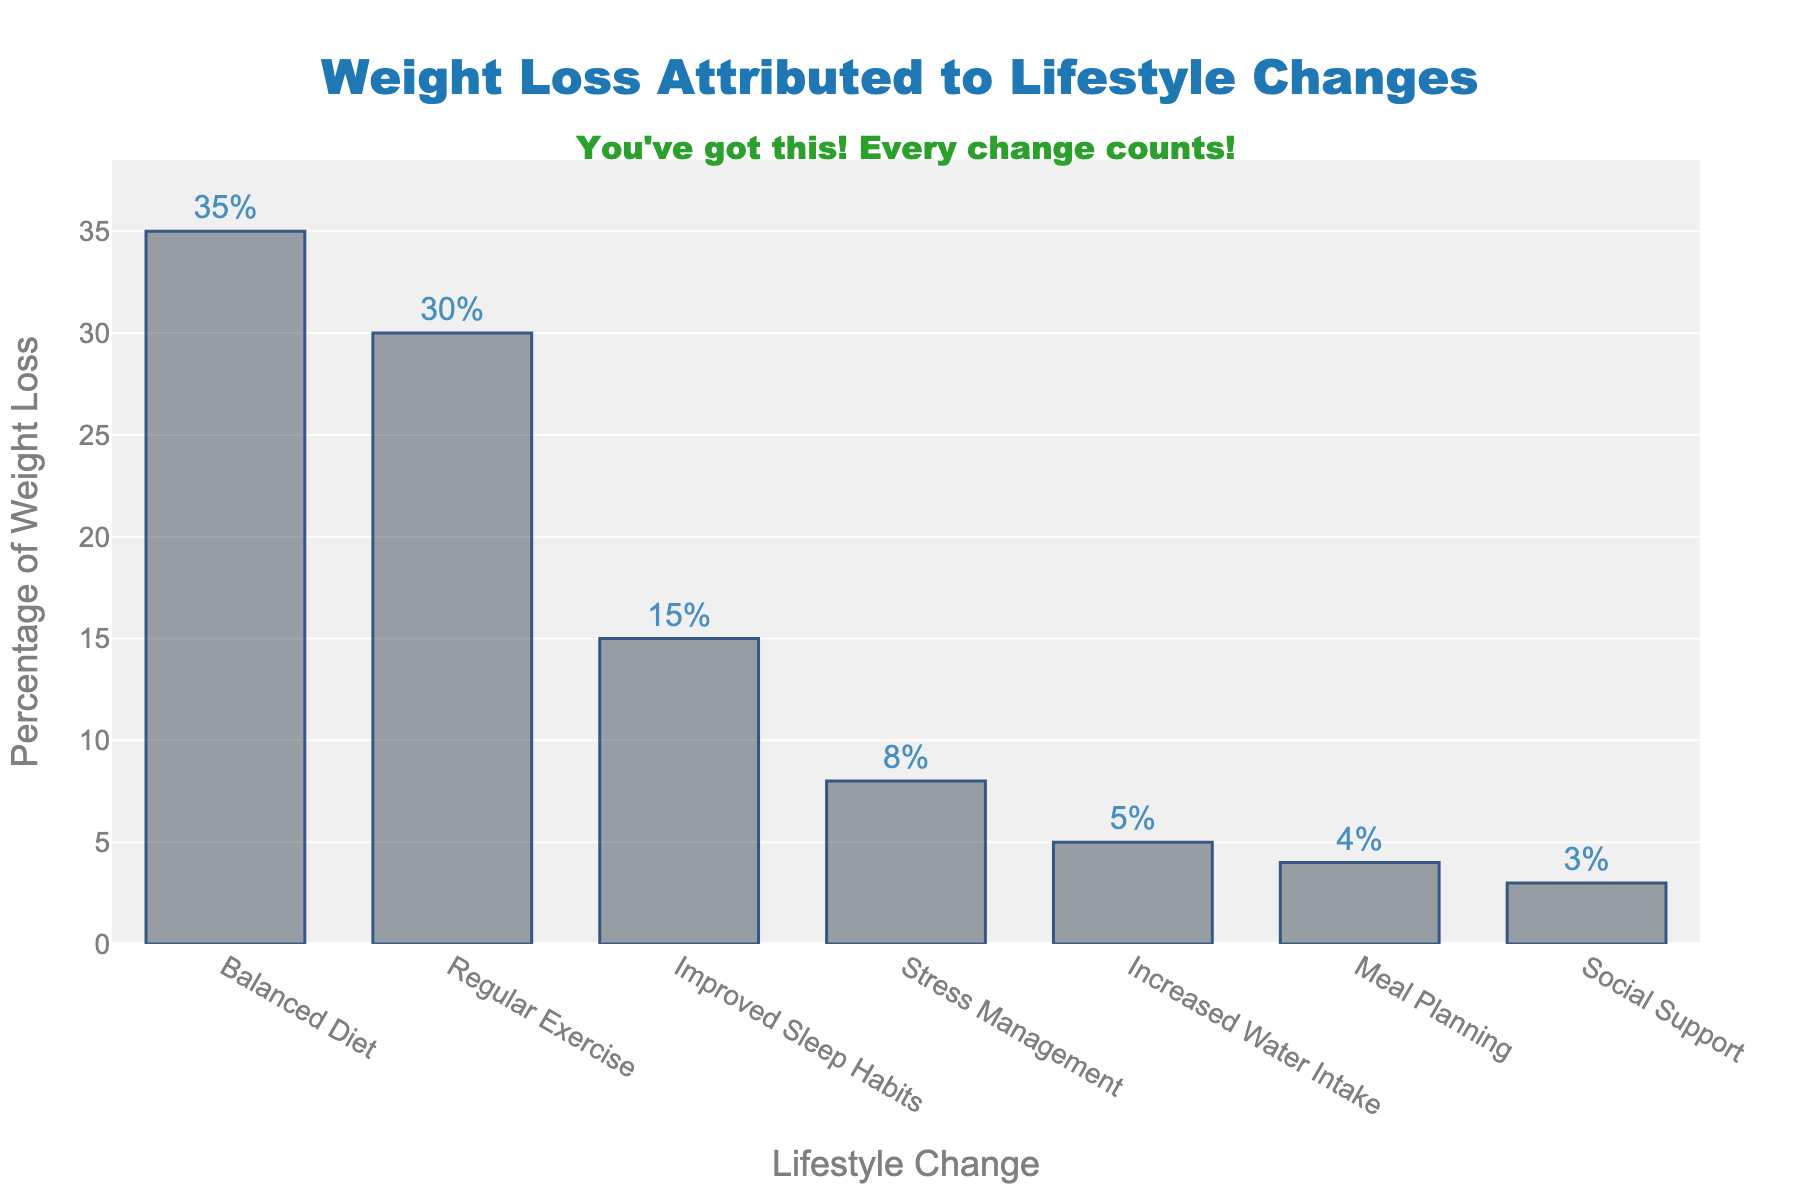Which lifestyle change contributes the most to weight loss? The tallest bar in the chart is labeled 'Balanced Diet' with a value of 35, indicating it contributes the most to weight loss.
Answer: Balanced Diet How much more is the percentage of weight loss due to a balanced diet compared to meal planning? The percentage for a balanced diet is 35 and for meal planning is 4. The difference is calculated as 35 - 4 = 31.
Answer: 31 Does regular exercise or improved sleep habits contribute more to weight loss? The bar for regular exercise is taller than the bar for improved sleep habits, indicating it contributes more. The values are 30 for exercise and 15 for sleep.
Answer: Regular Exercise Sum the percentages attributed to balanced diet, regular exercise, and improved sleep habits. Add the percentages: 35 (Balanced Diet) + 30 (Regular Exercise) + 15 (Improved Sleep Habits) = 80.
Answer: 80 What is the total percentage of weight loss attributed to all lifestyle changes? Add the percentages of all lifestyle changes: 35 + 30 + 15 + 8 + 5 + 4 + 3 = 100.
Answer: 100 How many lifestyle changes contribute less than 10% to weight loss? Count the bars with percentages less than 10: Stress Management (8), Increased Water Intake (5), Meal Planning (4), Social Support (3). There are 4 such bars.
Answer: 4 Which has a larger impact on weight loss: stress management or increased water intake? The percentage for stress management is 8, and for increased water intake is 5. 8 is greater than 5.
Answer: Stress Management What is the average percentage of weight loss attributed to social support, meal planning, and increased water intake? Add the percentages and divide by the number of items: (3 + 4 + 5) / 3 = 12 / 3 = 4.
Answer: 4 Compare the sum of the percentages of stress management and social support to the percentage of improved sleep habits. Sum the percentages of stress management and social support: 8 + 3 = 11. Compare this to improved sleep habits: 11 < 15.
Answer: Improved Sleep Habits 